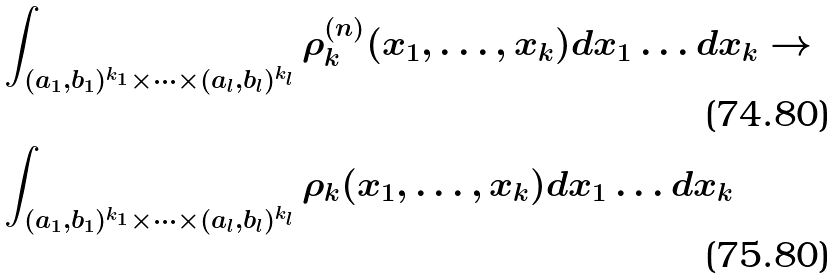Convert formula to latex. <formula><loc_0><loc_0><loc_500><loc_500>& \int _ { ( a _ { 1 } , b _ { 1 } ) ^ { k _ { 1 } } \times \dots \times ( a _ { l } , b _ { l } ) ^ { k _ { l } } } \rho _ { k } ^ { ( n ) } ( x _ { 1 } , \dots , x _ { k } ) d x _ { 1 } \dots d x _ { k } \to \\ & \int _ { ( a _ { 1 } , b _ { 1 } ) ^ { k _ { 1 } } \times \dots \times ( a _ { l } , b _ { l } ) ^ { k _ { l } } } \rho _ { k } ( x _ { 1 } , \dots , x _ { k } ) d x _ { 1 } \dots d x _ { k }</formula> 